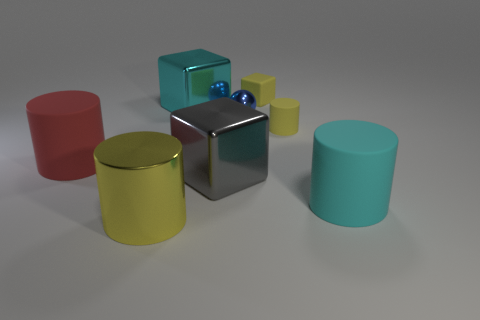Are there more gray metallic things behind the small matte cube than big gray metal blocks that are to the left of the big red cylinder?
Make the answer very short. No. What color is the tiny thing that is the same shape as the large red object?
Provide a short and direct response. Yellow. Are there any other things that are the same shape as the blue metal object?
Offer a very short reply. No. There is a large cyan matte thing; is it the same shape as the yellow rubber thing that is in front of the small yellow block?
Keep it short and to the point. Yes. What number of other objects are there of the same material as the yellow cube?
Your response must be concise. 3. There is a rubber block; is its color the same as the small matte thing in front of the blue metallic thing?
Your answer should be very brief. Yes. There is a cyan object behind the gray shiny block; what is it made of?
Ensure brevity in your answer.  Metal. Are there any rubber cubes that have the same color as the small matte cylinder?
Your answer should be very brief. Yes. There is a matte cylinder that is the same size as the cyan rubber thing; what color is it?
Keep it short and to the point. Red. How many large things are spheres or yellow cylinders?
Give a very brief answer. 1. 